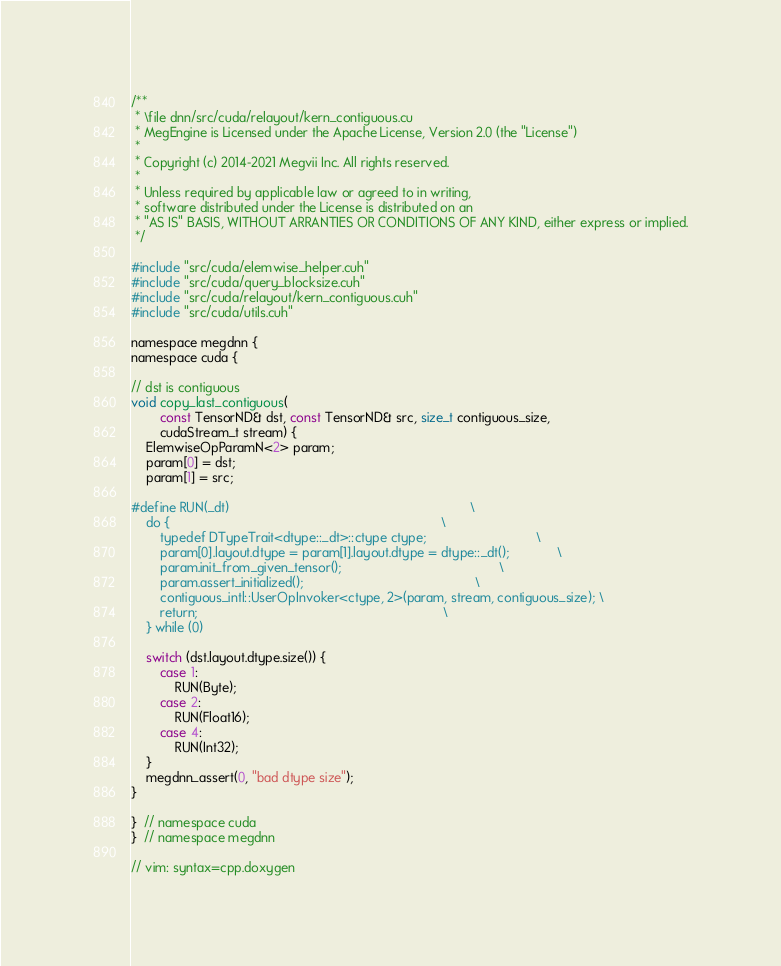<code> <loc_0><loc_0><loc_500><loc_500><_Cuda_>/**
 * \file dnn/src/cuda/relayout/kern_contiguous.cu
 * MegEngine is Licensed under the Apache License, Version 2.0 (the "License")
 *
 * Copyright (c) 2014-2021 Megvii Inc. All rights reserved.
 *
 * Unless required by applicable law or agreed to in writing,
 * software distributed under the License is distributed on an
 * "AS IS" BASIS, WITHOUT ARRANTIES OR CONDITIONS OF ANY KIND, either express or implied.
 */

#include "src/cuda/elemwise_helper.cuh"
#include "src/cuda/query_blocksize.cuh"
#include "src/cuda/relayout/kern_contiguous.cuh"
#include "src/cuda/utils.cuh"

namespace megdnn {
namespace cuda {

// dst is contiguous
void copy_last_contiguous(
        const TensorND& dst, const TensorND& src, size_t contiguous_size,
        cudaStream_t stream) {
    ElemwiseOpParamN<2> param;
    param[0] = dst;
    param[1] = src;

#define RUN(_dt)                                                                  \
    do {                                                                          \
        typedef DTypeTrait<dtype::_dt>::ctype ctype;                              \
        param[0].layout.dtype = param[1].layout.dtype = dtype::_dt();             \
        param.init_from_given_tensor();                                           \
        param.assert_initialized();                                               \
        contiguous_intl::UserOpInvoker<ctype, 2>(param, stream, contiguous_size); \
        return;                                                                   \
    } while (0)

    switch (dst.layout.dtype.size()) {
        case 1:
            RUN(Byte);
        case 2:
            RUN(Float16);
        case 4:
            RUN(Int32);
    }
    megdnn_assert(0, "bad dtype size");
}

}  // namespace cuda
}  // namespace megdnn

// vim: syntax=cpp.doxygen
</code> 